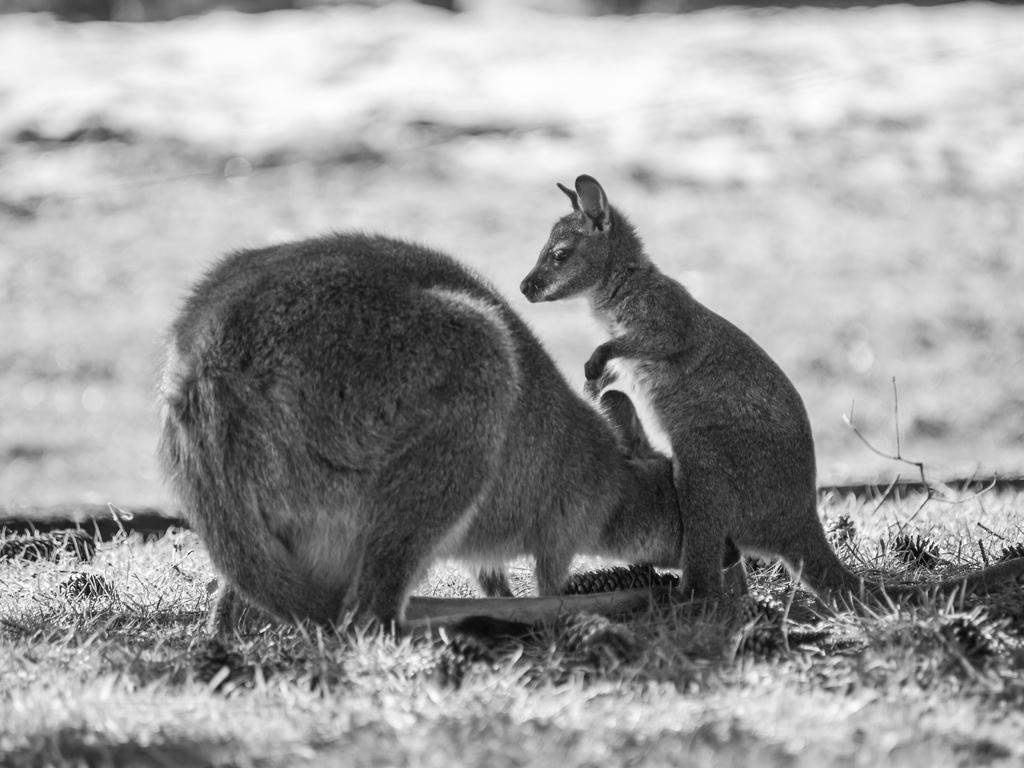How would you summarize this image in a sentence or two? It is the black and white image in which we can see that there are two kangaroos one beside the other. On the ground there is grass. 